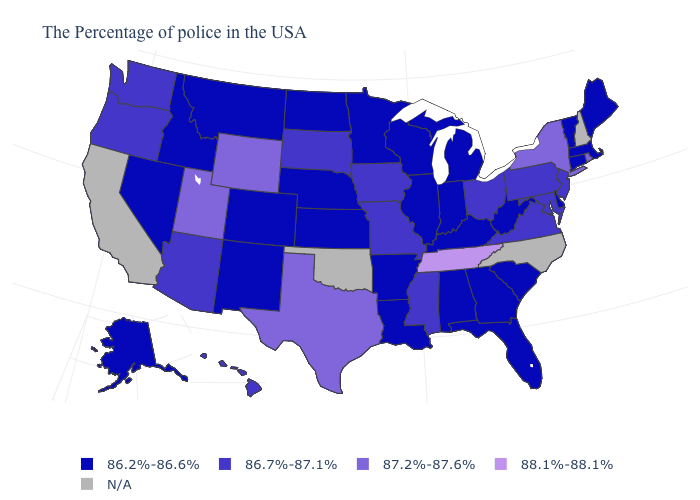How many symbols are there in the legend?
Quick response, please. 5. What is the highest value in the USA?
Short answer required. 88.1%-88.1%. Name the states that have a value in the range 86.2%-86.6%?
Keep it brief. Maine, Massachusetts, Vermont, Connecticut, Delaware, South Carolina, West Virginia, Florida, Georgia, Michigan, Kentucky, Indiana, Alabama, Wisconsin, Illinois, Louisiana, Arkansas, Minnesota, Kansas, Nebraska, North Dakota, Colorado, New Mexico, Montana, Idaho, Nevada, Alaska. What is the highest value in the MidWest ?
Write a very short answer. 86.7%-87.1%. What is the lowest value in the USA?
Short answer required. 86.2%-86.6%. Among the states that border Maryland , does West Virginia have the highest value?
Keep it brief. No. What is the value of Maine?
Be succinct. 86.2%-86.6%. Name the states that have a value in the range 87.2%-87.6%?
Answer briefly. Rhode Island, New York, Texas, Wyoming, Utah. Name the states that have a value in the range 86.2%-86.6%?
Give a very brief answer. Maine, Massachusetts, Vermont, Connecticut, Delaware, South Carolina, West Virginia, Florida, Georgia, Michigan, Kentucky, Indiana, Alabama, Wisconsin, Illinois, Louisiana, Arkansas, Minnesota, Kansas, Nebraska, North Dakota, Colorado, New Mexico, Montana, Idaho, Nevada, Alaska. What is the highest value in the USA?
Answer briefly. 88.1%-88.1%. Which states have the highest value in the USA?
Give a very brief answer. Tennessee. What is the highest value in the USA?
Answer briefly. 88.1%-88.1%. Does Tennessee have the highest value in the South?
Keep it brief. Yes. What is the value of Mississippi?
Give a very brief answer. 86.7%-87.1%. 